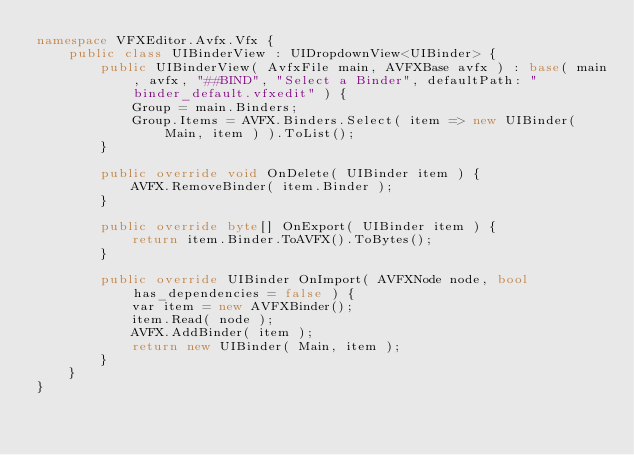Convert code to text. <code><loc_0><loc_0><loc_500><loc_500><_C#_>namespace VFXEditor.Avfx.Vfx {
    public class UIBinderView : UIDropdownView<UIBinder> {
        public UIBinderView( AvfxFile main, AVFXBase avfx ) : base( main, avfx, "##BIND", "Select a Binder", defaultPath: "binder_default.vfxedit" ) {
            Group = main.Binders;
            Group.Items = AVFX.Binders.Select( item => new UIBinder( Main, item ) ).ToList();
        }

        public override void OnDelete( UIBinder item ) {
            AVFX.RemoveBinder( item.Binder );
        }

        public override byte[] OnExport( UIBinder item ) {
            return item.Binder.ToAVFX().ToBytes();
        }

        public override UIBinder OnImport( AVFXNode node, bool has_dependencies = false ) {
            var item = new AVFXBinder();
            item.Read( node );
            AVFX.AddBinder( item );
            return new UIBinder( Main, item );
        }
    }
}
</code> 